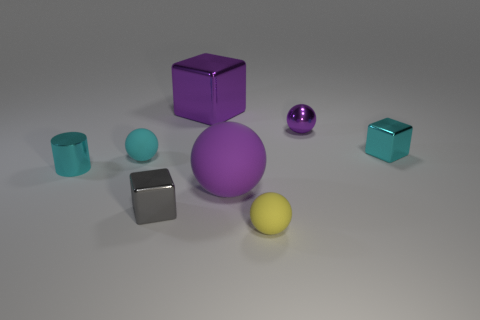Subtract all cyan balls. How many balls are left? 3 Subtract all cyan cubes. How many purple balls are left? 2 Add 1 tiny cyan balls. How many objects exist? 9 Subtract all yellow spheres. How many spheres are left? 3 Subtract all cylinders. How many objects are left? 7 Subtract 0 red cubes. How many objects are left? 8 Subtract all blue cylinders. Subtract all green balls. How many cylinders are left? 1 Subtract all tiny purple balls. Subtract all gray things. How many objects are left? 6 Add 8 purple cubes. How many purple cubes are left? 9 Add 6 tiny brown shiny cylinders. How many tiny brown shiny cylinders exist? 6 